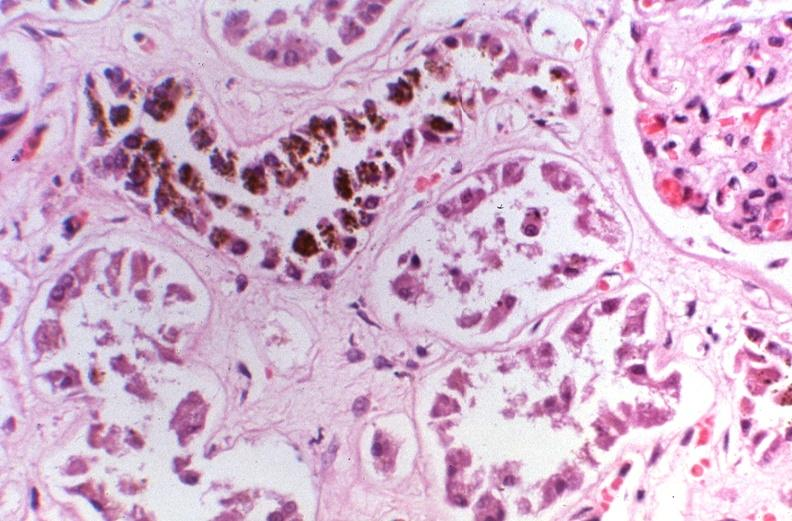where is this?
Answer the question using a single word or phrase. Urinary 